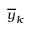Convert formula to latex. <formula><loc_0><loc_0><loc_500><loc_500>\overline { y } _ { k }</formula> 